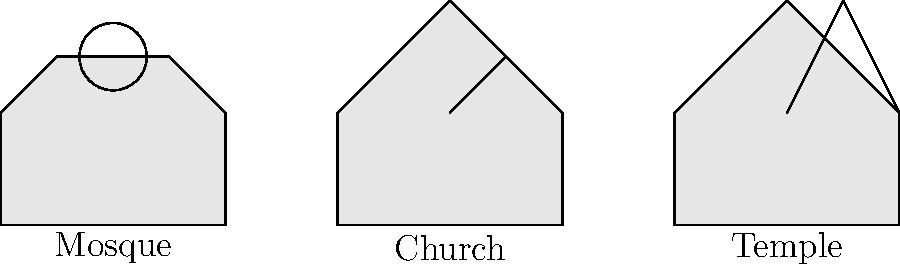Identify the key architectural features that distinguish the mosque from the church and temple in the diagram. What elements are unique to the mosque's layout? To answer this question, let's analyze the key features of each religious building:

1. Mosque:
   - Has a dome-like structure at the top center
   - Roof is relatively flat with a slight curve
   - No visible tower or spire

2. Church:
   - Has a pointed roof
   - Features a tall, narrow structure (likely a steeple or bell tower)
   - Cross-like shape at the top of the tall structure

3. Temple:
   - Has a pointed roof similar to the church
   - Features a triangular structure on top (likely representing a pagoda-style roof)
   - No tall tower or steeple

Unique elements of the mosque:
1. Dome: The circular structure on top is a distinctive feature of Islamic architecture, often representing the vault of heaven.
2. Flat roof: Unlike the pointed roofs of the church and temple, the mosque has a flatter roof profile.
3. Absence of tower: The mosque doesn't have a tall, narrow structure like the church's steeple or the temple's pagoda-style roof.

These features reflect the mosque's function as a place for communal prayer in Islam, where the dome often covers the main prayer hall and serves as a focal point for worshippers.
Answer: Dome, flat roof, absence of tower 